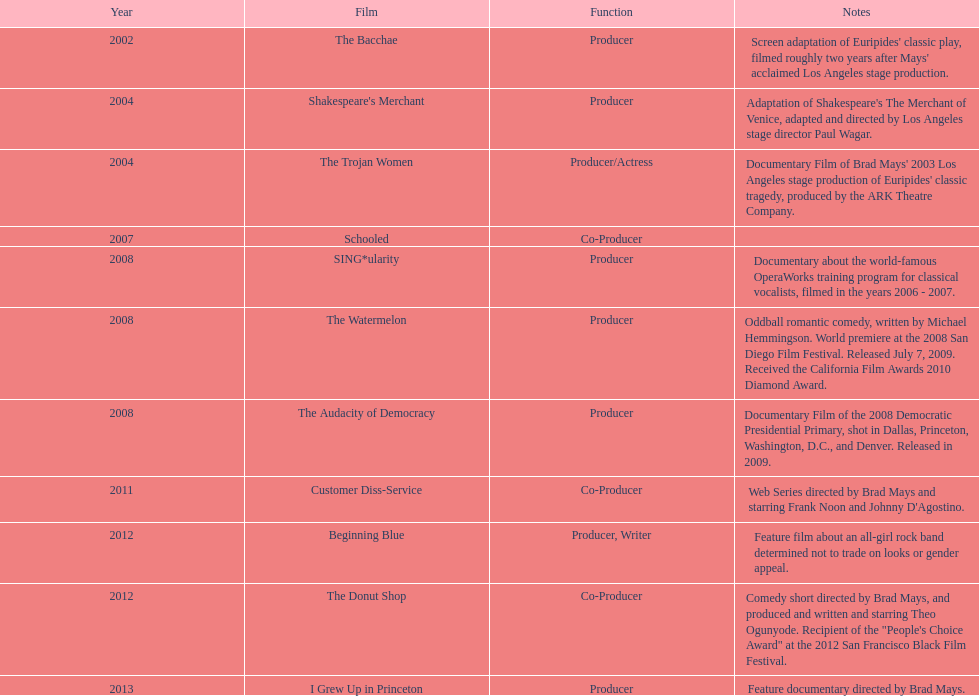Which documentary film was created between 2008 and 2011? The Audacity of Democracy. 